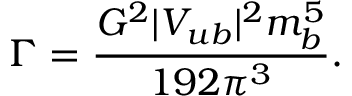<formula> <loc_0><loc_0><loc_500><loc_500>\Gamma = \frac { G ^ { 2 } | V _ { u b } | ^ { 2 } m _ { b } ^ { 5 } } { 1 9 2 \pi ^ { 3 } } .</formula> 